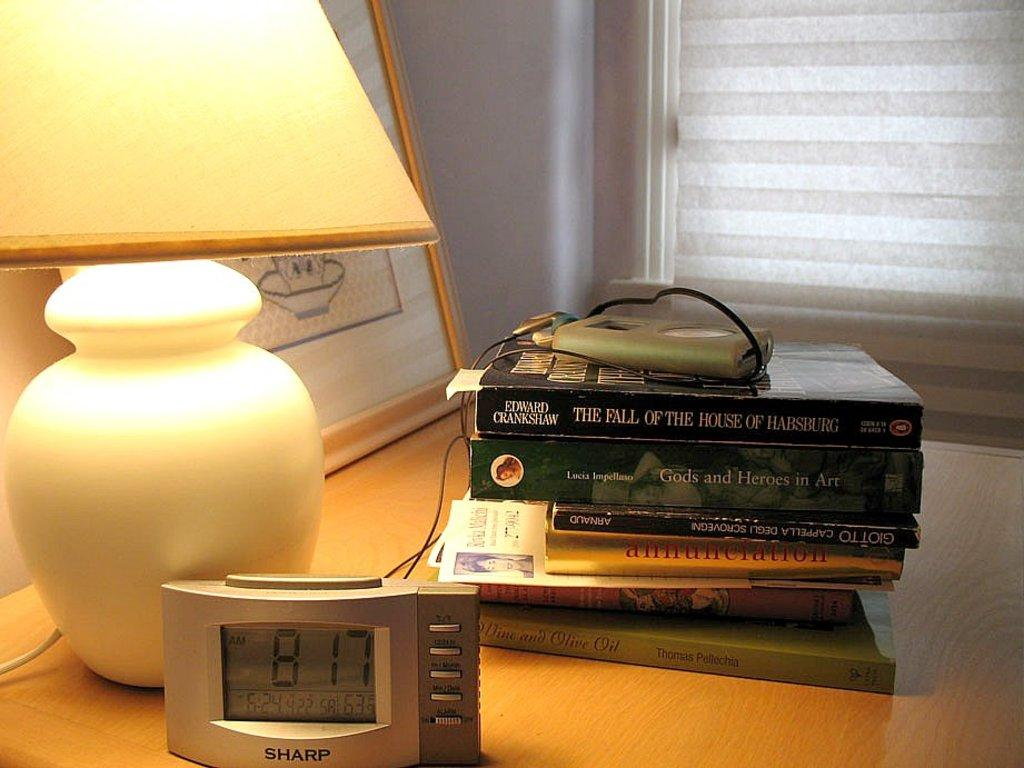<image>
Share a concise interpretation of the image provided. A Sharp brand clock sits on a bedside table reading 8:17 Am 